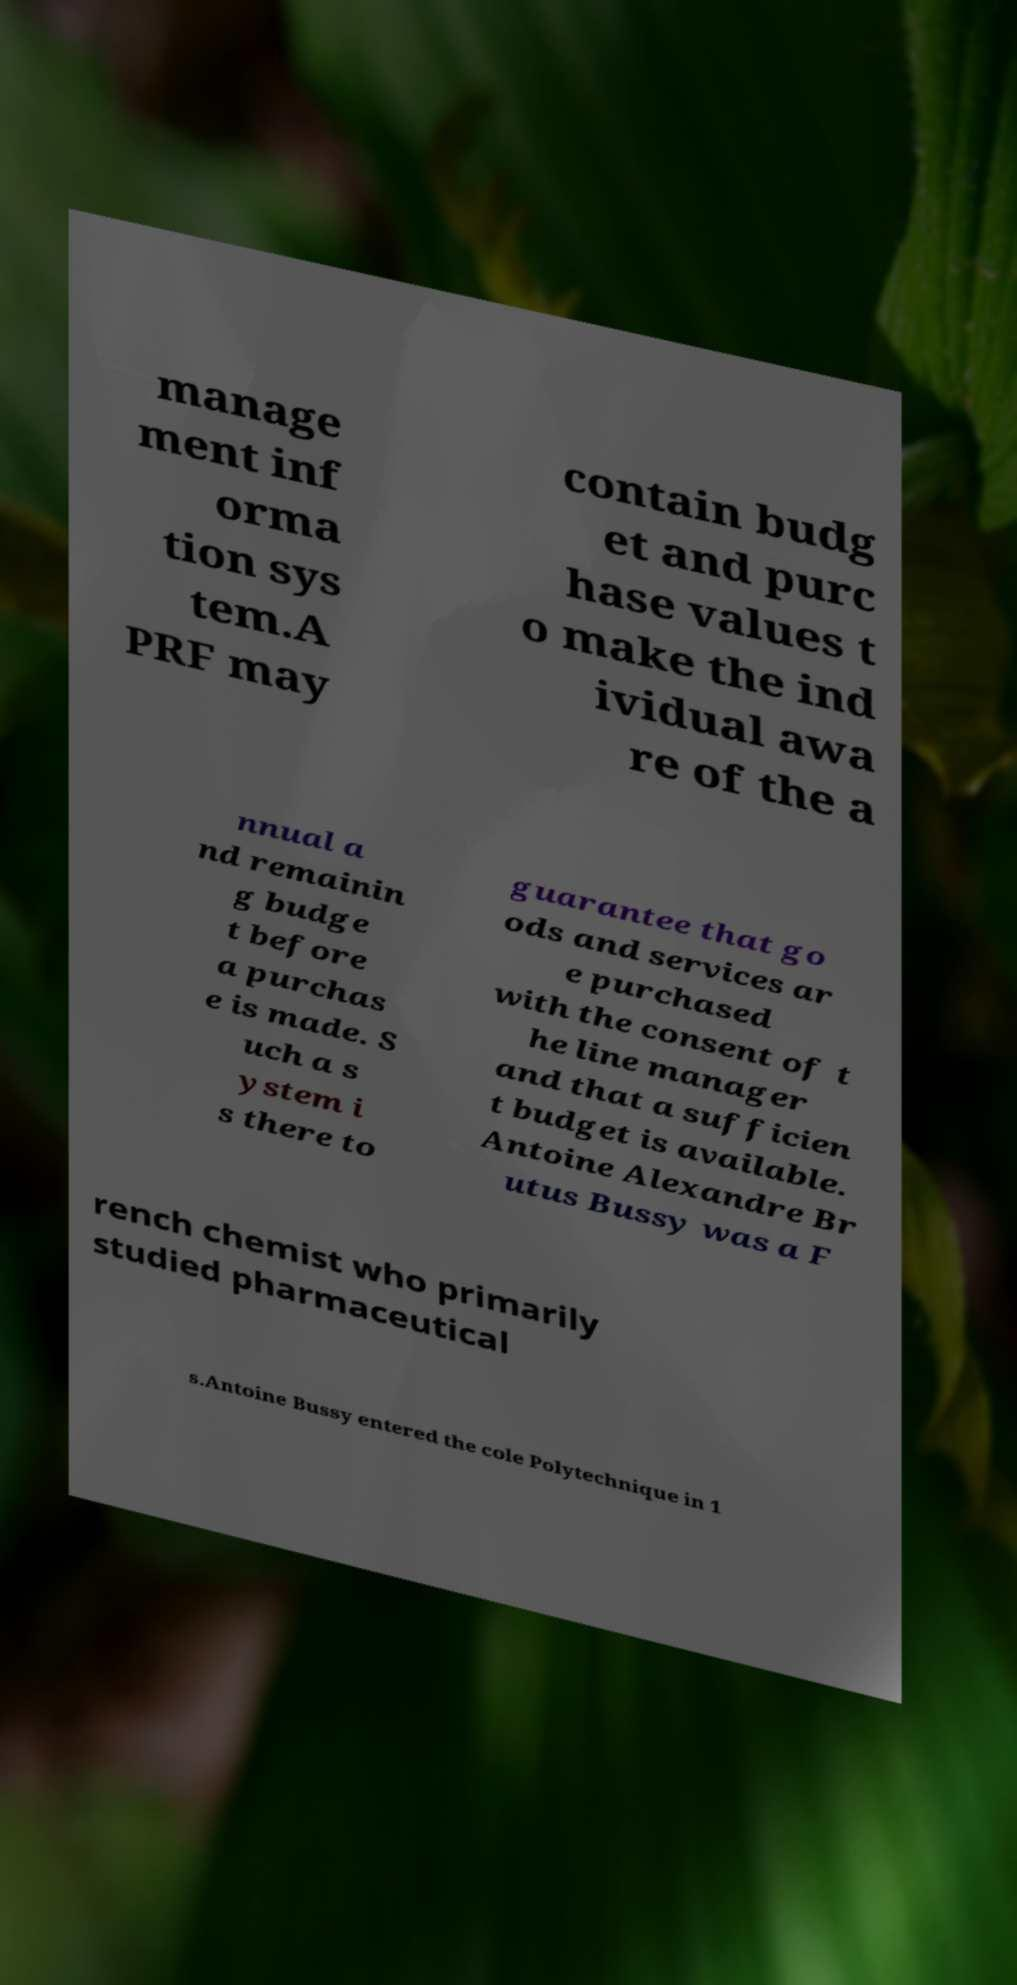What messages or text are displayed in this image? I need them in a readable, typed format. manage ment inf orma tion sys tem.A PRF may contain budg et and purc hase values t o make the ind ividual awa re of the a nnual a nd remainin g budge t before a purchas e is made. S uch a s ystem i s there to guarantee that go ods and services ar e purchased with the consent of t he line manager and that a sufficien t budget is available. Antoine Alexandre Br utus Bussy was a F rench chemist who primarily studied pharmaceutical s.Antoine Bussy entered the cole Polytechnique in 1 